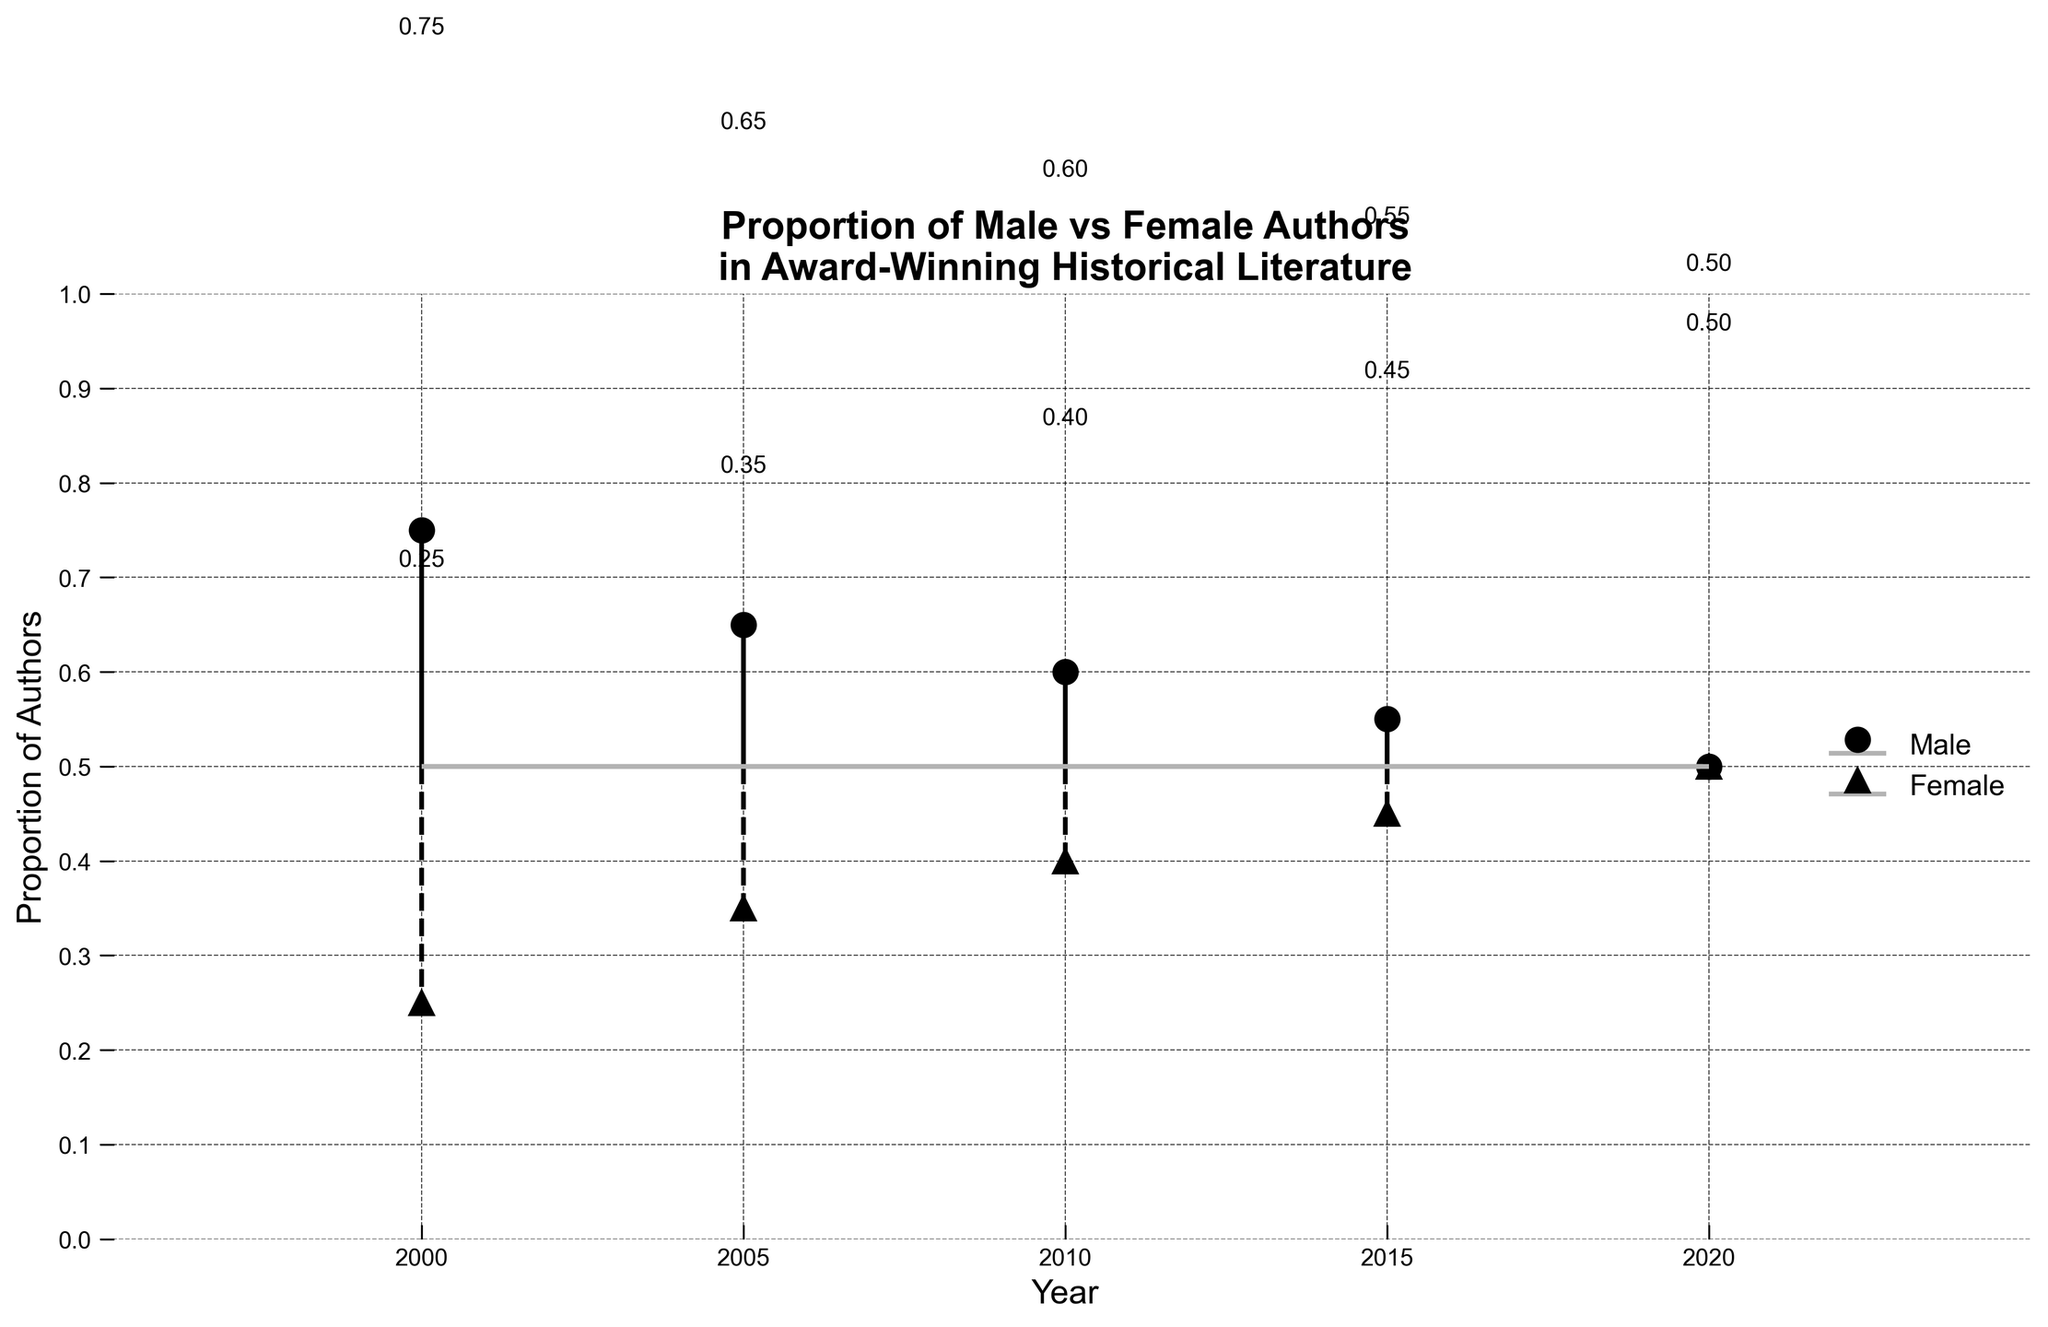What is the title of the plot? The title is usually at the top of the plot and it provides the main subject of the visual representation. In this case, it reads "Proportion of Male vs Female Authors in Award-Winning Historical Literature".
Answer: Proportion of Male vs Female Authors in Award-Winning Historical Literature What is the proportion of male authors in the year 2015? To find the proportion of male authors in 2015, locate the year 2015 on the x-axis and read the corresponding value from the stem plot for male authors. The data shows that the proportion is 0.55.
Answer: 0.55 Has there been any year where the proportion of male and female authors was equal? To check for equality between proportions, compare the points for male and female authors for each year. In 2020, both proportions meet at 0.50.
Answer: 2020 In which year did the proportion of female authors first exceed 0.40? Examine each year and identify the first instance where the female authors' proportion crosses 0.40. In 2010, the proportion of female authors was exactly 0.40, but in 2015, it exceeded this threshold at 0.45.
Answer: 2015 What is the trend for the male authors' proportion from 2000 to 2020? Observe the values on the plot for male authors' proportions over the years. The proportion starts at 0.75 in 2000 and gradually decreases to 0.50 in 2020. This indicates a declining trend.
Answer: Declining Compare the proportion of male and female authors in 2005. Which was higher, and by how much? For 2005, the proportion of male authors was 0.65 and for female authors, it was 0.35. To find the difference, subtract the female proportion from the male proportion: 0.65 - 0.35 = 0.30.
Answer: Male by 0.30 What is the average proportion of female authors from 2000 to 2020? Average is calculated by summing the values and dividing by the number of data points. Sum the proportions for female authors: 0.25 + 0.35 + 0.40 + 0.45 + 0.50 = 1.95. Divide by the number of years, which is 5: 1.95 / 5 = 0.39.
Answer: 0.39 Which year shows the smallest difference between the proportion of male and female authors? Calculate the absolute difference between male and female proportions for each year. The smallest difference occurs in 2020 with Proportion (0.50 - 0.50 = 0).
Answer: 2020 How does the change in female authors' proportion between 2015 and 2020 compare to the same interval for male authors? For female authors, the change is from 0.45 in 2015 to 0.50 in 2020, which is an increase of 0.05. For male authors, it changes from 0.55 in 2015 to 0.50 in 2020, a decrease of 0.05.
Answer: Female: +0.05, Male: -0.05 